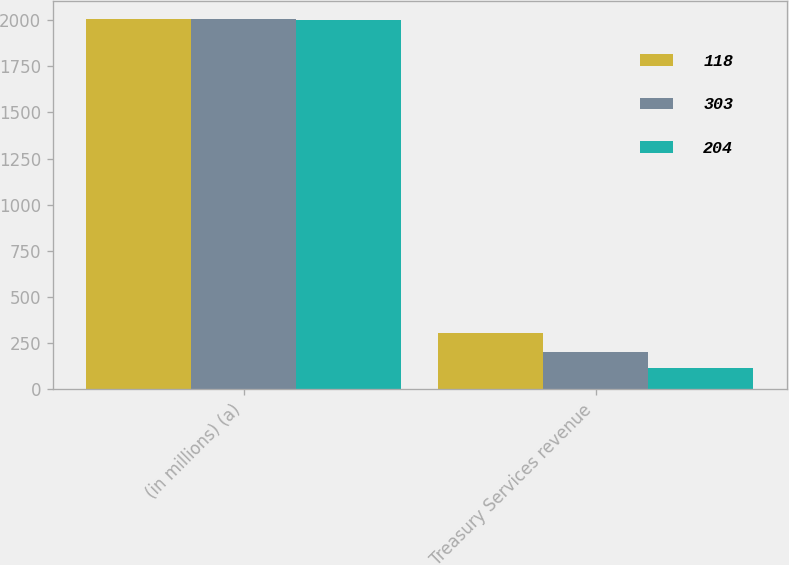<chart> <loc_0><loc_0><loc_500><loc_500><stacked_bar_chart><ecel><fcel>(in millions) (a)<fcel>Treasury Services revenue<nl><fcel>118<fcel>2005<fcel>303<nl><fcel>303<fcel>2004<fcel>204<nl><fcel>204<fcel>2003<fcel>118<nl></chart> 